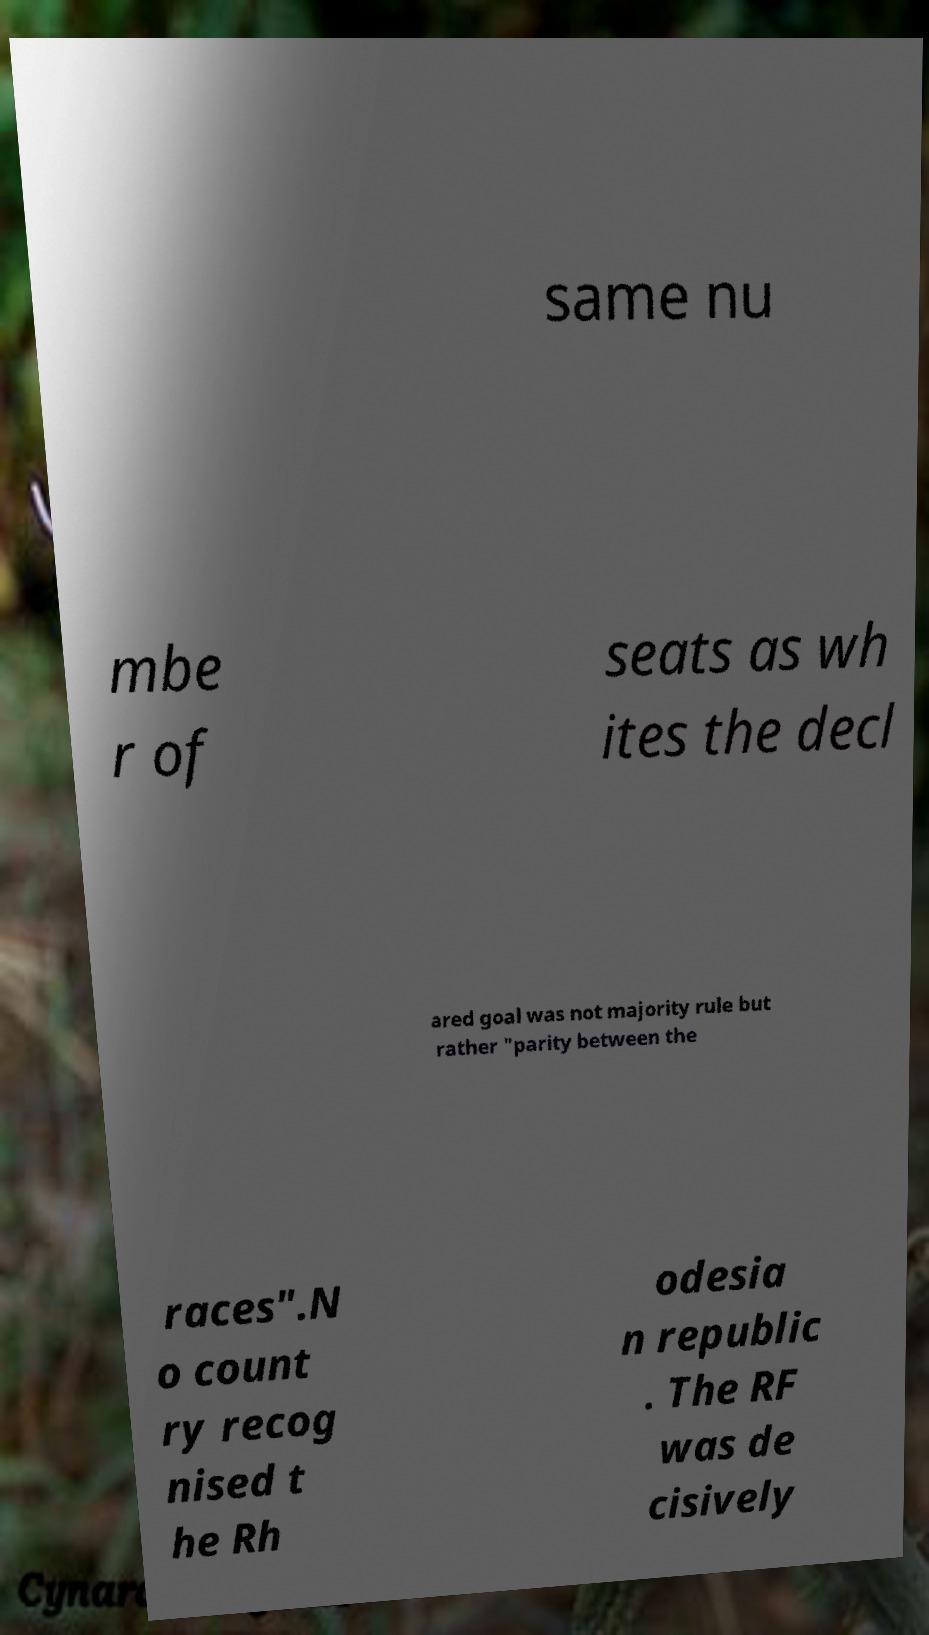Please read and relay the text visible in this image. What does it say? same nu mbe r of seats as wh ites the decl ared goal was not majority rule but rather "parity between the races".N o count ry recog nised t he Rh odesia n republic . The RF was de cisively 